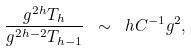Convert formula to latex. <formula><loc_0><loc_0><loc_500><loc_500>\frac { g ^ { 2 h } T _ { h } } { g ^ { 2 h - 2 } T _ { h - 1 } } \ \sim \ h C ^ { - 1 } g ^ { 2 } ,</formula> 